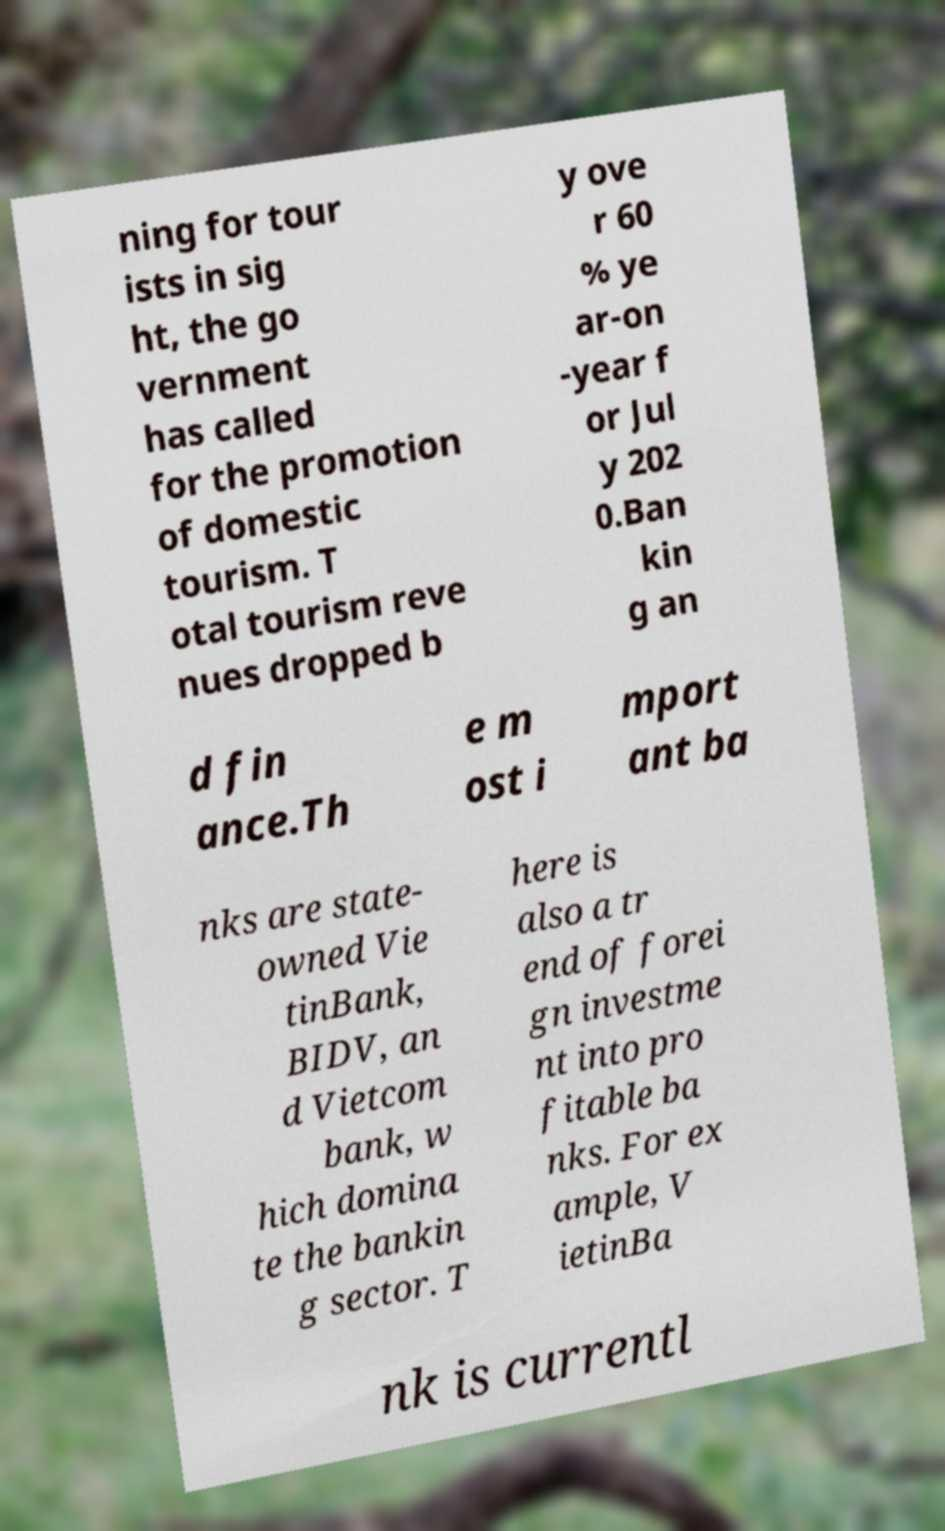Could you extract and type out the text from this image? ning for tour ists in sig ht, the go vernment has called for the promotion of domestic tourism. T otal tourism reve nues dropped b y ove r 60 % ye ar-on -year f or Jul y 202 0.Ban kin g an d fin ance.Th e m ost i mport ant ba nks are state- owned Vie tinBank, BIDV, an d Vietcom bank, w hich domina te the bankin g sector. T here is also a tr end of forei gn investme nt into pro fitable ba nks. For ex ample, V ietinBa nk is currentl 